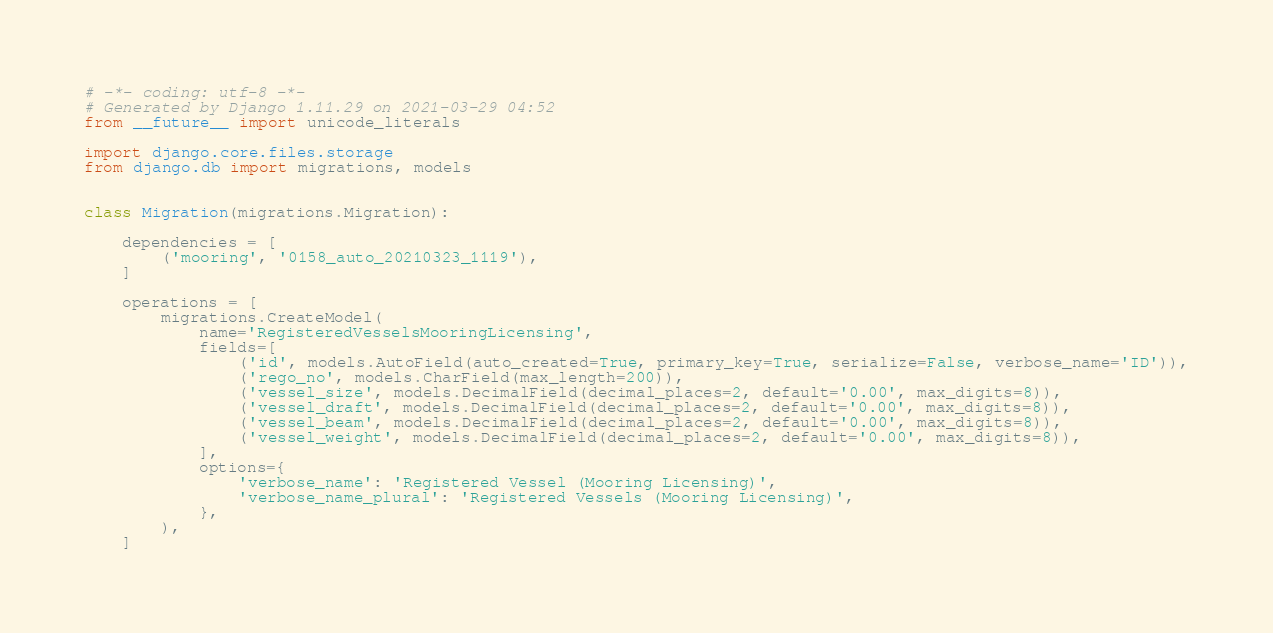<code> <loc_0><loc_0><loc_500><loc_500><_Python_># -*- coding: utf-8 -*-
# Generated by Django 1.11.29 on 2021-03-29 04:52
from __future__ import unicode_literals

import django.core.files.storage
from django.db import migrations, models


class Migration(migrations.Migration):

    dependencies = [
        ('mooring', '0158_auto_20210323_1119'),
    ]

    operations = [
        migrations.CreateModel(
            name='RegisteredVesselsMooringLicensing',
            fields=[
                ('id', models.AutoField(auto_created=True, primary_key=True, serialize=False, verbose_name='ID')),
                ('rego_no', models.CharField(max_length=200)),
                ('vessel_size', models.DecimalField(decimal_places=2, default='0.00', max_digits=8)),
                ('vessel_draft', models.DecimalField(decimal_places=2, default='0.00', max_digits=8)),
                ('vessel_beam', models.DecimalField(decimal_places=2, default='0.00', max_digits=8)),
                ('vessel_weight', models.DecimalField(decimal_places=2, default='0.00', max_digits=8)),
            ],
            options={
                'verbose_name': 'Registered Vessel (Mooring Licensing)',
                'verbose_name_plural': 'Registered Vessels (Mooring Licensing)',
            },
        ),
    ]
</code> 